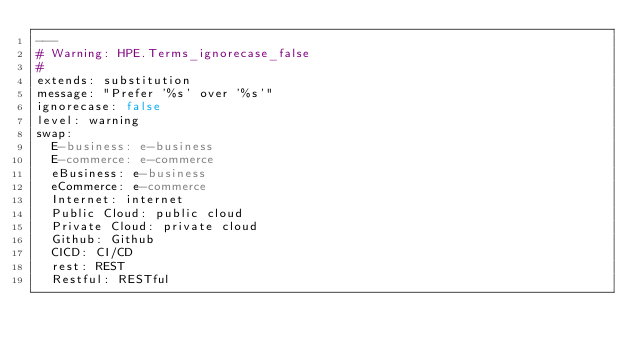Convert code to text. <code><loc_0><loc_0><loc_500><loc_500><_YAML_>---
# Warning: HPE.Terms_ignorecase_false
#
extends: substitution
message: "Prefer '%s' over '%s'"
ignorecase: false
level: warning
swap:
  E-business: e-business
  E-commerce: e-commerce
  eBusiness: e-business
  eCommerce: e-commerce
  Internet: internet
  Public Cloud: public cloud
  Private Cloud: private cloud
  Github: Github
  CICD: CI/CD
  rest: REST
  Restful: RESTful

  </code> 